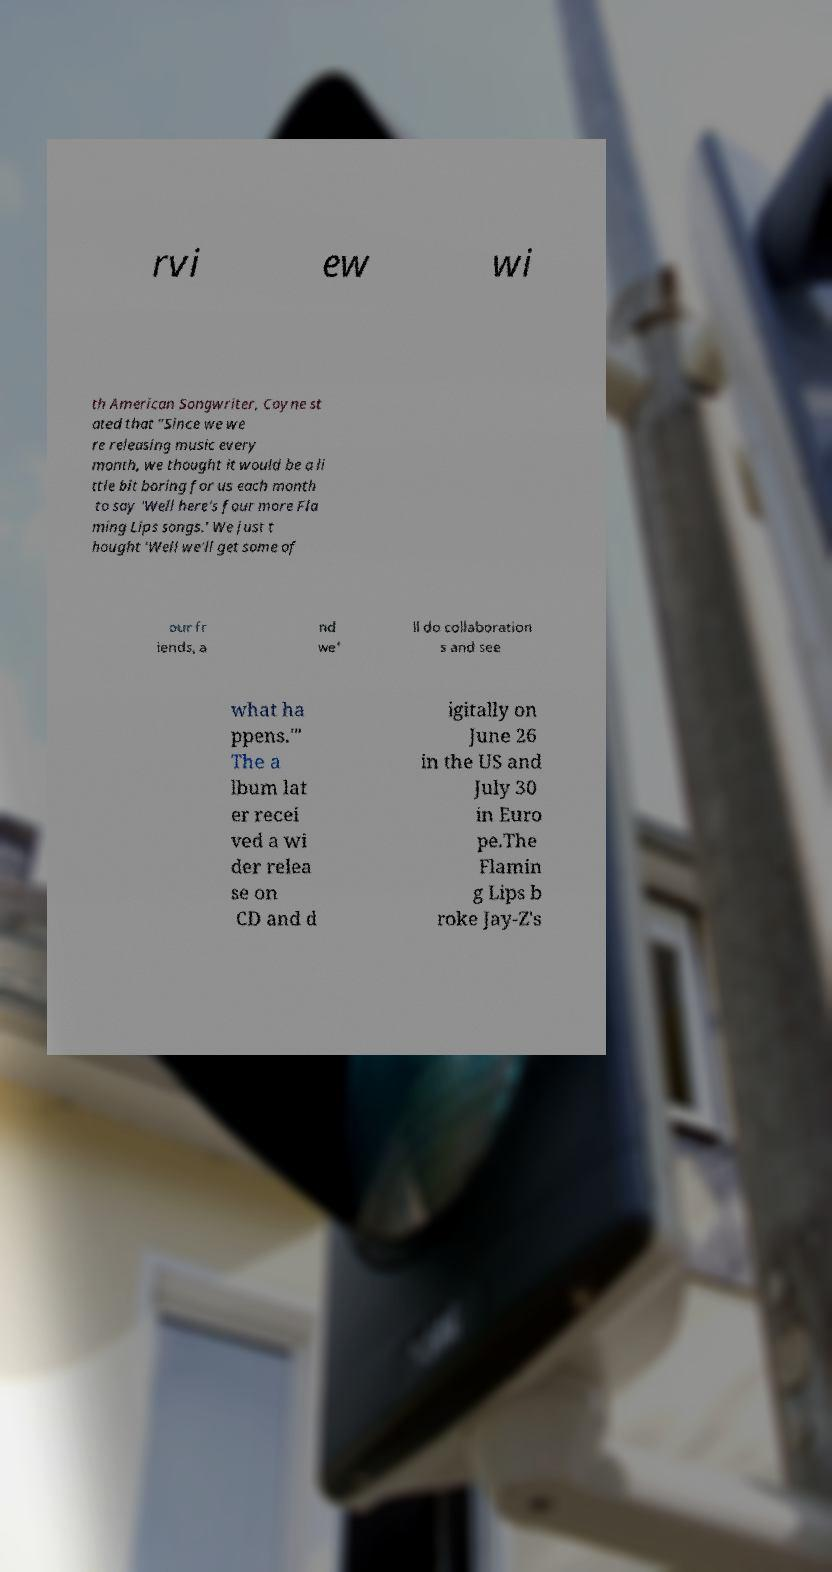Could you assist in decoding the text presented in this image and type it out clearly? rvi ew wi th American Songwriter, Coyne st ated that "Since we we re releasing music every month, we thought it would be a li ttle bit boring for us each month to say 'Well here's four more Fla ming Lips songs.' We just t hought 'Well we'll get some of our fr iends, a nd we' ll do collaboration s and see what ha ppens.'" The a lbum lat er recei ved a wi der relea se on CD and d igitally on June 26 in the US and July 30 in Euro pe.The Flamin g Lips b roke Jay-Z's 